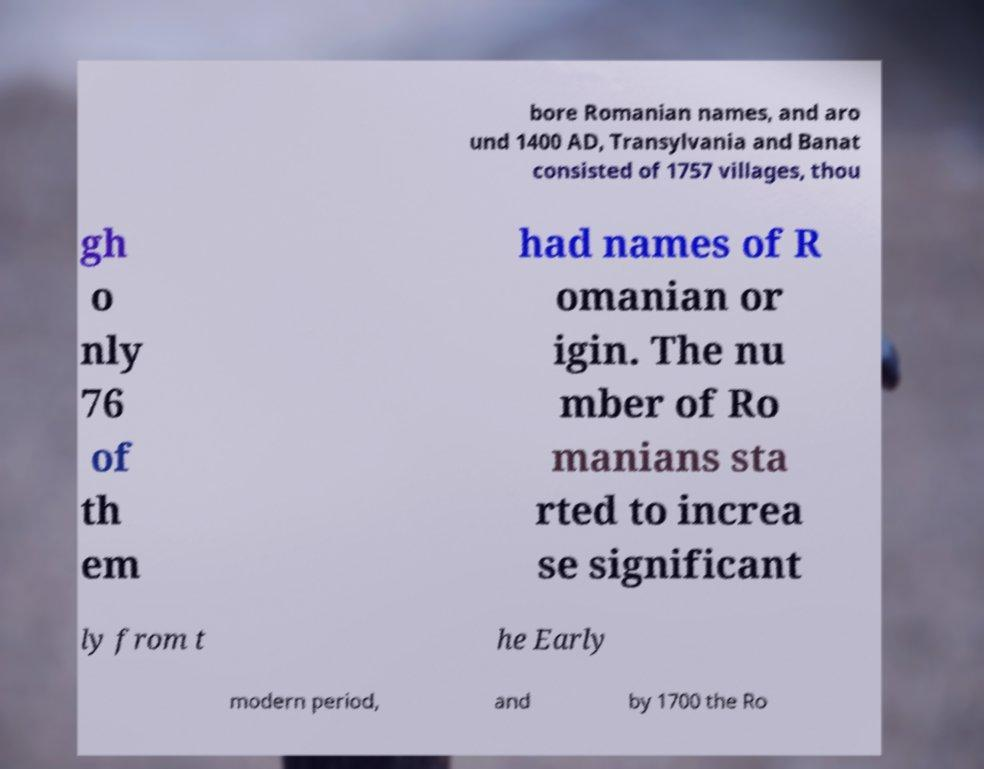For documentation purposes, I need the text within this image transcribed. Could you provide that? bore Romanian names, and aro und 1400 AD, Transylvania and Banat consisted of 1757 villages, thou gh o nly 76 of th em had names of R omanian or igin. The nu mber of Ro manians sta rted to increa se significant ly from t he Early modern period, and by 1700 the Ro 